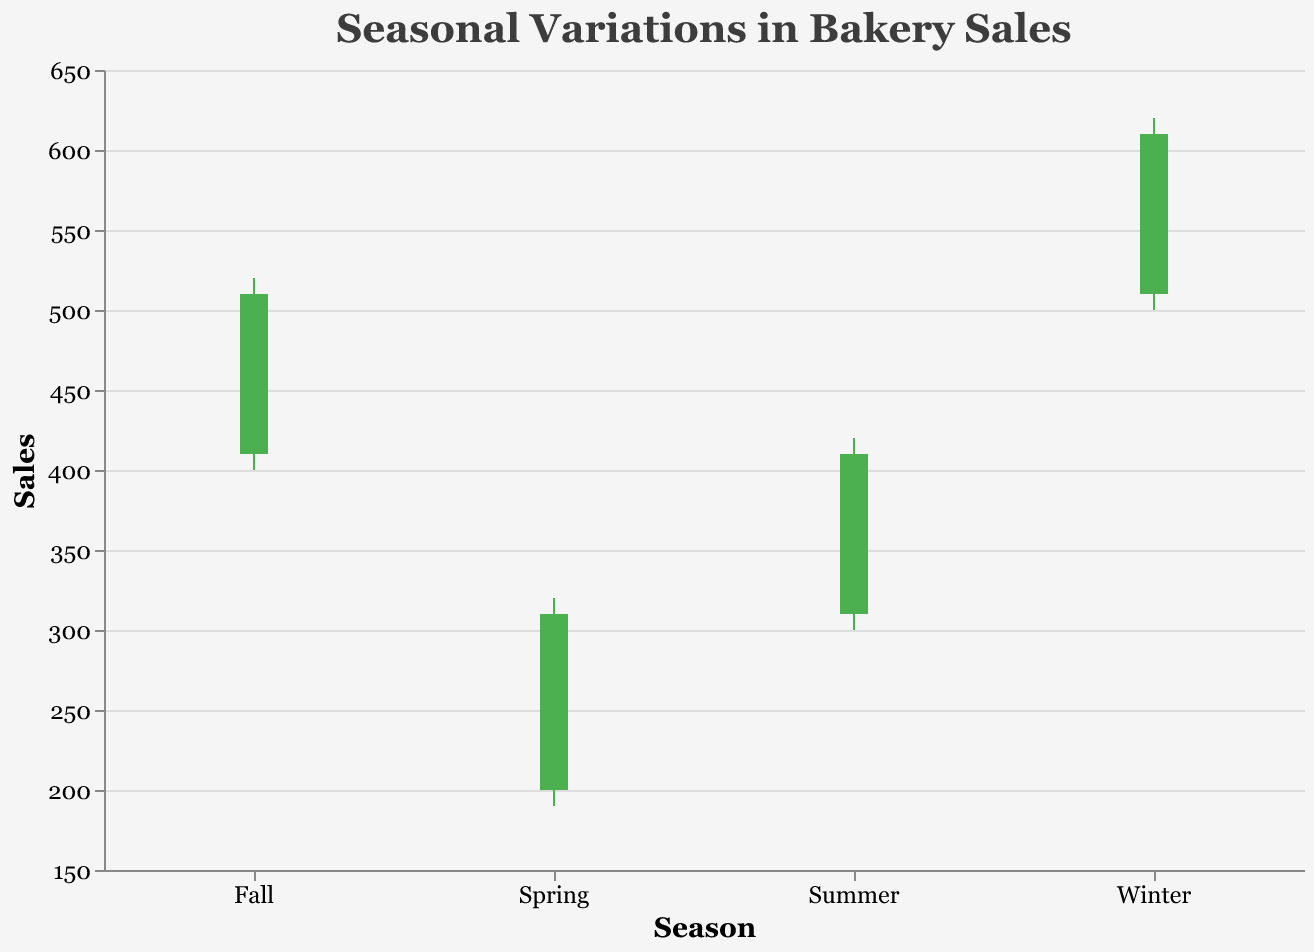What is the title of the figure? The title is a direct label on the figure and provides an immediate understanding of the plot's content.
Answer: Seasonal Variations in Bakery Sales How many weeks of sales data are plotted for each season? By reviewing the x-axis labels, which denote the weeks, and seeing there are four bars for each season, we can conclude that each season has 4 weeks of data.
Answer: 4 During which season did the sales reach the highest point, and what was that value? Inspecting the highest closing values across the candlestick plots indicates that sales peaked in Winter at 610.
Answer: Winter, 610 How does the color of a bar indicate sales performance on the candlestick chart? The color of the bars distinguishes whether sales increased (green) or decreased (red) from the opening to the closing of the week.
Answer: Green if increased, Red if decreased Which week in Spring saw the smallest increase in sales, and what is the difference between the Open and Close values for that week? By comparing the Open and Close prices for all Spring weeks (Week 1: 40, Week 2: 30, Week 3: 25, Week 4: 15), we determine Week 4 had the smallest increase. The difference is 310 - 295.
Answer: Week 4, 15 In which season did the sales consistently close at a higher value than they opened? By reviewing the colors of the candlestick bars for Fall (Weeks 1 to 4), all bars are green, indicating a consistent increase in sales throughout the season.
Answer: Fall During what week and season did the sales show the least variation between the High and Low values, and what was the range? To identify, find the minimal difference between High and Low values for all weeks, and Week 3 of Spring has the smallest range, being 40 (300 - 260).
Answer: Spring, Week 3, 40 What is the average closing value of bakery sales for Summer? Adding up the Close values for Summer weeks (350, 370, 395, 410) and dividing by 4 yields the average. (350 + 370 + 395 + 410) / 4 = 381.25
Answer: 381.25 Compare the highest closing sales value of Fall with the lowest closing sales value of Winter. What is the difference between them? The highest Fall closing value is 510 and the lowest Winter closing value is 540, resulting in a difference of 540 - 510 = 30.
Answer: 30 Which week had the highest weekly sales increase, and what was the percentage increase from Open to Close? Week 1 in Summer saw sales rise from 310 to 350, the highest increase by 40; the percentage increase is calculated as ((350 - 310) / 310) * 100 ≈ 12.9%.
Answer: Week 1, Summer, 12.9% 